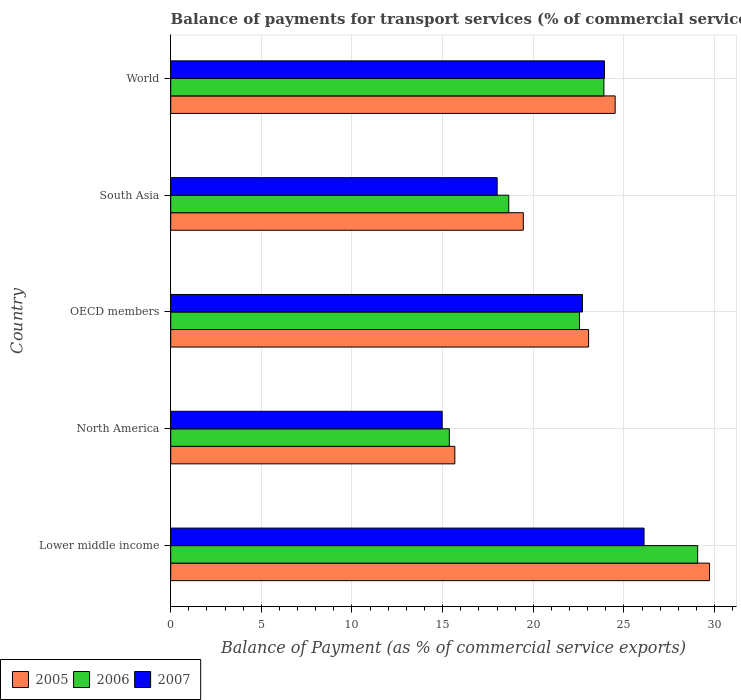How many different coloured bars are there?
Provide a short and direct response. 3. Are the number of bars per tick equal to the number of legend labels?
Keep it short and to the point. Yes. Are the number of bars on each tick of the Y-axis equal?
Offer a very short reply. Yes. How many bars are there on the 2nd tick from the top?
Offer a very short reply. 3. What is the label of the 4th group of bars from the top?
Offer a terse response. North America. In how many cases, is the number of bars for a given country not equal to the number of legend labels?
Provide a succinct answer. 0. What is the balance of payments for transport services in 2007 in Lower middle income?
Offer a very short reply. 26.11. Across all countries, what is the maximum balance of payments for transport services in 2007?
Provide a short and direct response. 26.11. Across all countries, what is the minimum balance of payments for transport services in 2006?
Your answer should be very brief. 15.37. In which country was the balance of payments for transport services in 2005 maximum?
Your answer should be compact. Lower middle income. In which country was the balance of payments for transport services in 2005 minimum?
Keep it short and to the point. North America. What is the total balance of payments for transport services in 2007 in the graph?
Provide a short and direct response. 105.73. What is the difference between the balance of payments for transport services in 2007 in OECD members and that in World?
Keep it short and to the point. -1.21. What is the difference between the balance of payments for transport services in 2006 in South Asia and the balance of payments for transport services in 2005 in World?
Ensure brevity in your answer.  -5.87. What is the average balance of payments for transport services in 2007 per country?
Make the answer very short. 21.15. What is the difference between the balance of payments for transport services in 2007 and balance of payments for transport services in 2006 in OECD members?
Your response must be concise. 0.16. In how many countries, is the balance of payments for transport services in 2005 greater than 18 %?
Offer a very short reply. 4. What is the ratio of the balance of payments for transport services in 2007 in North America to that in World?
Ensure brevity in your answer.  0.63. What is the difference between the highest and the second highest balance of payments for transport services in 2006?
Your answer should be compact. 5.17. What is the difference between the highest and the lowest balance of payments for transport services in 2005?
Keep it short and to the point. 14.05. In how many countries, is the balance of payments for transport services in 2006 greater than the average balance of payments for transport services in 2006 taken over all countries?
Make the answer very short. 3. How many bars are there?
Your answer should be compact. 15. Does the graph contain any zero values?
Your answer should be compact. No. Does the graph contain grids?
Provide a short and direct response. Yes. What is the title of the graph?
Provide a short and direct response. Balance of payments for transport services (% of commercial service exports). Does "2000" appear as one of the legend labels in the graph?
Your answer should be very brief. No. What is the label or title of the X-axis?
Ensure brevity in your answer.  Balance of Payment (as % of commercial service exports). What is the Balance of Payment (as % of commercial service exports) of 2005 in Lower middle income?
Offer a very short reply. 29.72. What is the Balance of Payment (as % of commercial service exports) of 2006 in Lower middle income?
Provide a short and direct response. 29.07. What is the Balance of Payment (as % of commercial service exports) of 2007 in Lower middle income?
Provide a short and direct response. 26.11. What is the Balance of Payment (as % of commercial service exports) in 2005 in North America?
Ensure brevity in your answer.  15.67. What is the Balance of Payment (as % of commercial service exports) in 2006 in North America?
Your answer should be very brief. 15.37. What is the Balance of Payment (as % of commercial service exports) of 2007 in North America?
Ensure brevity in your answer.  14.97. What is the Balance of Payment (as % of commercial service exports) in 2005 in OECD members?
Your answer should be compact. 23.05. What is the Balance of Payment (as % of commercial service exports) of 2006 in OECD members?
Your answer should be very brief. 22.55. What is the Balance of Payment (as % of commercial service exports) in 2007 in OECD members?
Give a very brief answer. 22.71. What is the Balance of Payment (as % of commercial service exports) in 2005 in South Asia?
Provide a succinct answer. 19.45. What is the Balance of Payment (as % of commercial service exports) of 2006 in South Asia?
Make the answer very short. 18.65. What is the Balance of Payment (as % of commercial service exports) of 2007 in South Asia?
Your answer should be very brief. 18.01. What is the Balance of Payment (as % of commercial service exports) in 2005 in World?
Ensure brevity in your answer.  24.52. What is the Balance of Payment (as % of commercial service exports) of 2006 in World?
Your answer should be very brief. 23.9. What is the Balance of Payment (as % of commercial service exports) in 2007 in World?
Make the answer very short. 23.93. Across all countries, what is the maximum Balance of Payment (as % of commercial service exports) of 2005?
Ensure brevity in your answer.  29.72. Across all countries, what is the maximum Balance of Payment (as % of commercial service exports) in 2006?
Provide a short and direct response. 29.07. Across all countries, what is the maximum Balance of Payment (as % of commercial service exports) in 2007?
Give a very brief answer. 26.11. Across all countries, what is the minimum Balance of Payment (as % of commercial service exports) of 2005?
Offer a terse response. 15.67. Across all countries, what is the minimum Balance of Payment (as % of commercial service exports) of 2006?
Ensure brevity in your answer.  15.37. Across all countries, what is the minimum Balance of Payment (as % of commercial service exports) of 2007?
Ensure brevity in your answer.  14.97. What is the total Balance of Payment (as % of commercial service exports) in 2005 in the graph?
Make the answer very short. 112.42. What is the total Balance of Payment (as % of commercial service exports) of 2006 in the graph?
Your response must be concise. 109.54. What is the total Balance of Payment (as % of commercial service exports) of 2007 in the graph?
Keep it short and to the point. 105.73. What is the difference between the Balance of Payment (as % of commercial service exports) of 2005 in Lower middle income and that in North America?
Provide a succinct answer. 14.05. What is the difference between the Balance of Payment (as % of commercial service exports) of 2006 in Lower middle income and that in North America?
Provide a short and direct response. 13.7. What is the difference between the Balance of Payment (as % of commercial service exports) of 2007 in Lower middle income and that in North America?
Your answer should be very brief. 11.14. What is the difference between the Balance of Payment (as % of commercial service exports) of 2005 in Lower middle income and that in OECD members?
Offer a very short reply. 6.67. What is the difference between the Balance of Payment (as % of commercial service exports) in 2006 in Lower middle income and that in OECD members?
Keep it short and to the point. 6.52. What is the difference between the Balance of Payment (as % of commercial service exports) of 2007 in Lower middle income and that in OECD members?
Provide a short and direct response. 3.4. What is the difference between the Balance of Payment (as % of commercial service exports) in 2005 in Lower middle income and that in South Asia?
Your answer should be compact. 10.27. What is the difference between the Balance of Payment (as % of commercial service exports) of 2006 in Lower middle income and that in South Asia?
Offer a terse response. 10.42. What is the difference between the Balance of Payment (as % of commercial service exports) of 2007 in Lower middle income and that in South Asia?
Provide a short and direct response. 8.1. What is the difference between the Balance of Payment (as % of commercial service exports) of 2005 in Lower middle income and that in World?
Provide a succinct answer. 5.21. What is the difference between the Balance of Payment (as % of commercial service exports) of 2006 in Lower middle income and that in World?
Make the answer very short. 5.17. What is the difference between the Balance of Payment (as % of commercial service exports) in 2007 in Lower middle income and that in World?
Give a very brief answer. 2.19. What is the difference between the Balance of Payment (as % of commercial service exports) of 2005 in North America and that in OECD members?
Offer a terse response. -7.38. What is the difference between the Balance of Payment (as % of commercial service exports) in 2006 in North America and that in OECD members?
Make the answer very short. -7.18. What is the difference between the Balance of Payment (as % of commercial service exports) of 2007 in North America and that in OECD members?
Keep it short and to the point. -7.74. What is the difference between the Balance of Payment (as % of commercial service exports) of 2005 in North America and that in South Asia?
Your response must be concise. -3.78. What is the difference between the Balance of Payment (as % of commercial service exports) of 2006 in North America and that in South Asia?
Keep it short and to the point. -3.28. What is the difference between the Balance of Payment (as % of commercial service exports) of 2007 in North America and that in South Asia?
Your answer should be compact. -3.03. What is the difference between the Balance of Payment (as % of commercial service exports) in 2005 in North America and that in World?
Provide a succinct answer. -8.84. What is the difference between the Balance of Payment (as % of commercial service exports) in 2006 in North America and that in World?
Offer a very short reply. -8.53. What is the difference between the Balance of Payment (as % of commercial service exports) in 2007 in North America and that in World?
Keep it short and to the point. -8.95. What is the difference between the Balance of Payment (as % of commercial service exports) of 2006 in OECD members and that in South Asia?
Your answer should be very brief. 3.9. What is the difference between the Balance of Payment (as % of commercial service exports) in 2007 in OECD members and that in South Asia?
Your answer should be very brief. 4.7. What is the difference between the Balance of Payment (as % of commercial service exports) in 2005 in OECD members and that in World?
Offer a very short reply. -1.47. What is the difference between the Balance of Payment (as % of commercial service exports) of 2006 in OECD members and that in World?
Provide a short and direct response. -1.35. What is the difference between the Balance of Payment (as % of commercial service exports) of 2007 in OECD members and that in World?
Give a very brief answer. -1.21. What is the difference between the Balance of Payment (as % of commercial service exports) in 2005 in South Asia and that in World?
Give a very brief answer. -5.07. What is the difference between the Balance of Payment (as % of commercial service exports) in 2006 in South Asia and that in World?
Make the answer very short. -5.25. What is the difference between the Balance of Payment (as % of commercial service exports) in 2007 in South Asia and that in World?
Provide a short and direct response. -5.92. What is the difference between the Balance of Payment (as % of commercial service exports) in 2005 in Lower middle income and the Balance of Payment (as % of commercial service exports) in 2006 in North America?
Provide a succinct answer. 14.35. What is the difference between the Balance of Payment (as % of commercial service exports) in 2005 in Lower middle income and the Balance of Payment (as % of commercial service exports) in 2007 in North America?
Give a very brief answer. 14.75. What is the difference between the Balance of Payment (as % of commercial service exports) in 2006 in Lower middle income and the Balance of Payment (as % of commercial service exports) in 2007 in North America?
Ensure brevity in your answer.  14.09. What is the difference between the Balance of Payment (as % of commercial service exports) of 2005 in Lower middle income and the Balance of Payment (as % of commercial service exports) of 2006 in OECD members?
Offer a very short reply. 7.17. What is the difference between the Balance of Payment (as % of commercial service exports) of 2005 in Lower middle income and the Balance of Payment (as % of commercial service exports) of 2007 in OECD members?
Make the answer very short. 7.01. What is the difference between the Balance of Payment (as % of commercial service exports) in 2006 in Lower middle income and the Balance of Payment (as % of commercial service exports) in 2007 in OECD members?
Your answer should be compact. 6.36. What is the difference between the Balance of Payment (as % of commercial service exports) of 2005 in Lower middle income and the Balance of Payment (as % of commercial service exports) of 2006 in South Asia?
Offer a terse response. 11.08. What is the difference between the Balance of Payment (as % of commercial service exports) of 2005 in Lower middle income and the Balance of Payment (as % of commercial service exports) of 2007 in South Asia?
Keep it short and to the point. 11.72. What is the difference between the Balance of Payment (as % of commercial service exports) in 2006 in Lower middle income and the Balance of Payment (as % of commercial service exports) in 2007 in South Asia?
Your answer should be compact. 11.06. What is the difference between the Balance of Payment (as % of commercial service exports) in 2005 in Lower middle income and the Balance of Payment (as % of commercial service exports) in 2006 in World?
Give a very brief answer. 5.83. What is the difference between the Balance of Payment (as % of commercial service exports) in 2005 in Lower middle income and the Balance of Payment (as % of commercial service exports) in 2007 in World?
Offer a terse response. 5.8. What is the difference between the Balance of Payment (as % of commercial service exports) of 2006 in Lower middle income and the Balance of Payment (as % of commercial service exports) of 2007 in World?
Offer a very short reply. 5.14. What is the difference between the Balance of Payment (as % of commercial service exports) of 2005 in North America and the Balance of Payment (as % of commercial service exports) of 2006 in OECD members?
Your response must be concise. -6.88. What is the difference between the Balance of Payment (as % of commercial service exports) of 2005 in North America and the Balance of Payment (as % of commercial service exports) of 2007 in OECD members?
Your response must be concise. -7.04. What is the difference between the Balance of Payment (as % of commercial service exports) in 2006 in North America and the Balance of Payment (as % of commercial service exports) in 2007 in OECD members?
Your response must be concise. -7.34. What is the difference between the Balance of Payment (as % of commercial service exports) of 2005 in North America and the Balance of Payment (as % of commercial service exports) of 2006 in South Asia?
Offer a terse response. -2.98. What is the difference between the Balance of Payment (as % of commercial service exports) of 2005 in North America and the Balance of Payment (as % of commercial service exports) of 2007 in South Asia?
Make the answer very short. -2.34. What is the difference between the Balance of Payment (as % of commercial service exports) of 2006 in North America and the Balance of Payment (as % of commercial service exports) of 2007 in South Asia?
Provide a short and direct response. -2.64. What is the difference between the Balance of Payment (as % of commercial service exports) of 2005 in North America and the Balance of Payment (as % of commercial service exports) of 2006 in World?
Your answer should be very brief. -8.22. What is the difference between the Balance of Payment (as % of commercial service exports) in 2005 in North America and the Balance of Payment (as % of commercial service exports) in 2007 in World?
Give a very brief answer. -8.25. What is the difference between the Balance of Payment (as % of commercial service exports) in 2006 in North America and the Balance of Payment (as % of commercial service exports) in 2007 in World?
Give a very brief answer. -8.56. What is the difference between the Balance of Payment (as % of commercial service exports) of 2005 in OECD members and the Balance of Payment (as % of commercial service exports) of 2006 in South Asia?
Offer a terse response. 4.4. What is the difference between the Balance of Payment (as % of commercial service exports) of 2005 in OECD members and the Balance of Payment (as % of commercial service exports) of 2007 in South Asia?
Make the answer very short. 5.04. What is the difference between the Balance of Payment (as % of commercial service exports) of 2006 in OECD members and the Balance of Payment (as % of commercial service exports) of 2007 in South Asia?
Your answer should be compact. 4.54. What is the difference between the Balance of Payment (as % of commercial service exports) in 2005 in OECD members and the Balance of Payment (as % of commercial service exports) in 2006 in World?
Provide a succinct answer. -0.85. What is the difference between the Balance of Payment (as % of commercial service exports) in 2005 in OECD members and the Balance of Payment (as % of commercial service exports) in 2007 in World?
Your answer should be very brief. -0.87. What is the difference between the Balance of Payment (as % of commercial service exports) in 2006 in OECD members and the Balance of Payment (as % of commercial service exports) in 2007 in World?
Your response must be concise. -1.38. What is the difference between the Balance of Payment (as % of commercial service exports) in 2005 in South Asia and the Balance of Payment (as % of commercial service exports) in 2006 in World?
Your answer should be compact. -4.45. What is the difference between the Balance of Payment (as % of commercial service exports) in 2005 in South Asia and the Balance of Payment (as % of commercial service exports) in 2007 in World?
Give a very brief answer. -4.47. What is the difference between the Balance of Payment (as % of commercial service exports) in 2006 in South Asia and the Balance of Payment (as % of commercial service exports) in 2007 in World?
Offer a terse response. -5.28. What is the average Balance of Payment (as % of commercial service exports) in 2005 per country?
Provide a succinct answer. 22.48. What is the average Balance of Payment (as % of commercial service exports) of 2006 per country?
Make the answer very short. 21.91. What is the average Balance of Payment (as % of commercial service exports) of 2007 per country?
Offer a very short reply. 21.15. What is the difference between the Balance of Payment (as % of commercial service exports) of 2005 and Balance of Payment (as % of commercial service exports) of 2006 in Lower middle income?
Make the answer very short. 0.66. What is the difference between the Balance of Payment (as % of commercial service exports) of 2005 and Balance of Payment (as % of commercial service exports) of 2007 in Lower middle income?
Provide a succinct answer. 3.61. What is the difference between the Balance of Payment (as % of commercial service exports) of 2006 and Balance of Payment (as % of commercial service exports) of 2007 in Lower middle income?
Offer a very short reply. 2.96. What is the difference between the Balance of Payment (as % of commercial service exports) in 2005 and Balance of Payment (as % of commercial service exports) in 2006 in North America?
Your response must be concise. 0.3. What is the difference between the Balance of Payment (as % of commercial service exports) in 2005 and Balance of Payment (as % of commercial service exports) in 2007 in North America?
Provide a succinct answer. 0.7. What is the difference between the Balance of Payment (as % of commercial service exports) in 2006 and Balance of Payment (as % of commercial service exports) in 2007 in North America?
Provide a succinct answer. 0.4. What is the difference between the Balance of Payment (as % of commercial service exports) of 2005 and Balance of Payment (as % of commercial service exports) of 2006 in OECD members?
Give a very brief answer. 0.5. What is the difference between the Balance of Payment (as % of commercial service exports) of 2005 and Balance of Payment (as % of commercial service exports) of 2007 in OECD members?
Ensure brevity in your answer.  0.34. What is the difference between the Balance of Payment (as % of commercial service exports) in 2006 and Balance of Payment (as % of commercial service exports) in 2007 in OECD members?
Provide a succinct answer. -0.16. What is the difference between the Balance of Payment (as % of commercial service exports) in 2005 and Balance of Payment (as % of commercial service exports) in 2006 in South Asia?
Provide a short and direct response. 0.8. What is the difference between the Balance of Payment (as % of commercial service exports) in 2005 and Balance of Payment (as % of commercial service exports) in 2007 in South Asia?
Your answer should be very brief. 1.44. What is the difference between the Balance of Payment (as % of commercial service exports) in 2006 and Balance of Payment (as % of commercial service exports) in 2007 in South Asia?
Give a very brief answer. 0.64. What is the difference between the Balance of Payment (as % of commercial service exports) of 2005 and Balance of Payment (as % of commercial service exports) of 2006 in World?
Your answer should be very brief. 0.62. What is the difference between the Balance of Payment (as % of commercial service exports) of 2005 and Balance of Payment (as % of commercial service exports) of 2007 in World?
Give a very brief answer. 0.59. What is the difference between the Balance of Payment (as % of commercial service exports) in 2006 and Balance of Payment (as % of commercial service exports) in 2007 in World?
Your answer should be compact. -0.03. What is the ratio of the Balance of Payment (as % of commercial service exports) in 2005 in Lower middle income to that in North America?
Your answer should be compact. 1.9. What is the ratio of the Balance of Payment (as % of commercial service exports) in 2006 in Lower middle income to that in North America?
Provide a succinct answer. 1.89. What is the ratio of the Balance of Payment (as % of commercial service exports) in 2007 in Lower middle income to that in North America?
Provide a short and direct response. 1.74. What is the ratio of the Balance of Payment (as % of commercial service exports) of 2005 in Lower middle income to that in OECD members?
Make the answer very short. 1.29. What is the ratio of the Balance of Payment (as % of commercial service exports) of 2006 in Lower middle income to that in OECD members?
Provide a short and direct response. 1.29. What is the ratio of the Balance of Payment (as % of commercial service exports) of 2007 in Lower middle income to that in OECD members?
Make the answer very short. 1.15. What is the ratio of the Balance of Payment (as % of commercial service exports) of 2005 in Lower middle income to that in South Asia?
Offer a terse response. 1.53. What is the ratio of the Balance of Payment (as % of commercial service exports) in 2006 in Lower middle income to that in South Asia?
Your response must be concise. 1.56. What is the ratio of the Balance of Payment (as % of commercial service exports) of 2007 in Lower middle income to that in South Asia?
Provide a short and direct response. 1.45. What is the ratio of the Balance of Payment (as % of commercial service exports) of 2005 in Lower middle income to that in World?
Ensure brevity in your answer.  1.21. What is the ratio of the Balance of Payment (as % of commercial service exports) in 2006 in Lower middle income to that in World?
Keep it short and to the point. 1.22. What is the ratio of the Balance of Payment (as % of commercial service exports) in 2007 in Lower middle income to that in World?
Give a very brief answer. 1.09. What is the ratio of the Balance of Payment (as % of commercial service exports) of 2005 in North America to that in OECD members?
Offer a terse response. 0.68. What is the ratio of the Balance of Payment (as % of commercial service exports) of 2006 in North America to that in OECD members?
Your answer should be compact. 0.68. What is the ratio of the Balance of Payment (as % of commercial service exports) in 2007 in North America to that in OECD members?
Offer a very short reply. 0.66. What is the ratio of the Balance of Payment (as % of commercial service exports) of 2005 in North America to that in South Asia?
Keep it short and to the point. 0.81. What is the ratio of the Balance of Payment (as % of commercial service exports) in 2006 in North America to that in South Asia?
Your response must be concise. 0.82. What is the ratio of the Balance of Payment (as % of commercial service exports) of 2007 in North America to that in South Asia?
Your answer should be very brief. 0.83. What is the ratio of the Balance of Payment (as % of commercial service exports) in 2005 in North America to that in World?
Your answer should be very brief. 0.64. What is the ratio of the Balance of Payment (as % of commercial service exports) in 2006 in North America to that in World?
Make the answer very short. 0.64. What is the ratio of the Balance of Payment (as % of commercial service exports) of 2007 in North America to that in World?
Provide a short and direct response. 0.63. What is the ratio of the Balance of Payment (as % of commercial service exports) of 2005 in OECD members to that in South Asia?
Make the answer very short. 1.19. What is the ratio of the Balance of Payment (as % of commercial service exports) in 2006 in OECD members to that in South Asia?
Offer a very short reply. 1.21. What is the ratio of the Balance of Payment (as % of commercial service exports) of 2007 in OECD members to that in South Asia?
Keep it short and to the point. 1.26. What is the ratio of the Balance of Payment (as % of commercial service exports) in 2005 in OECD members to that in World?
Offer a terse response. 0.94. What is the ratio of the Balance of Payment (as % of commercial service exports) in 2006 in OECD members to that in World?
Offer a very short reply. 0.94. What is the ratio of the Balance of Payment (as % of commercial service exports) of 2007 in OECD members to that in World?
Provide a succinct answer. 0.95. What is the ratio of the Balance of Payment (as % of commercial service exports) in 2005 in South Asia to that in World?
Your answer should be very brief. 0.79. What is the ratio of the Balance of Payment (as % of commercial service exports) of 2006 in South Asia to that in World?
Provide a succinct answer. 0.78. What is the ratio of the Balance of Payment (as % of commercial service exports) of 2007 in South Asia to that in World?
Make the answer very short. 0.75. What is the difference between the highest and the second highest Balance of Payment (as % of commercial service exports) in 2005?
Make the answer very short. 5.21. What is the difference between the highest and the second highest Balance of Payment (as % of commercial service exports) of 2006?
Your answer should be very brief. 5.17. What is the difference between the highest and the second highest Balance of Payment (as % of commercial service exports) in 2007?
Keep it short and to the point. 2.19. What is the difference between the highest and the lowest Balance of Payment (as % of commercial service exports) of 2005?
Ensure brevity in your answer.  14.05. What is the difference between the highest and the lowest Balance of Payment (as % of commercial service exports) of 2006?
Give a very brief answer. 13.7. What is the difference between the highest and the lowest Balance of Payment (as % of commercial service exports) of 2007?
Keep it short and to the point. 11.14. 